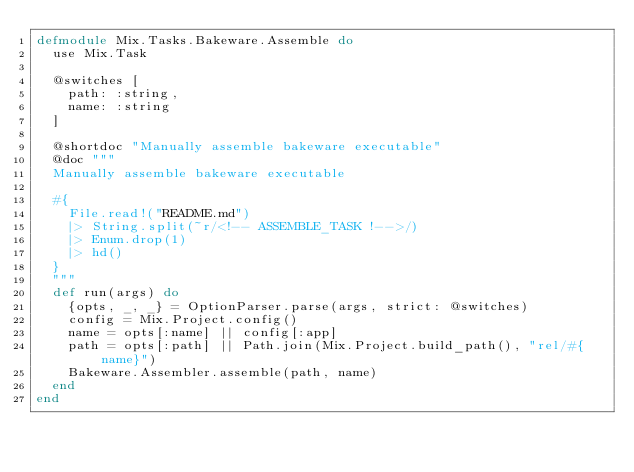Convert code to text. <code><loc_0><loc_0><loc_500><loc_500><_Elixir_>defmodule Mix.Tasks.Bakeware.Assemble do
  use Mix.Task

  @switches [
    path: :string,
    name: :string
  ]

  @shortdoc "Manually assemble bakeware executable"
  @doc """
  Manually assemble bakeware executable

  #{
    File.read!("README.md")
    |> String.split(~r/<!-- ASSEMBLE_TASK !-->/)
    |> Enum.drop(1)
    |> hd()
  }
  """
  def run(args) do
    {opts, _, _} = OptionParser.parse(args, strict: @switches)
    config = Mix.Project.config()
    name = opts[:name] || config[:app]
    path = opts[:path] || Path.join(Mix.Project.build_path(), "rel/#{name}")
    Bakeware.Assembler.assemble(path, name)
  end
end
</code> 